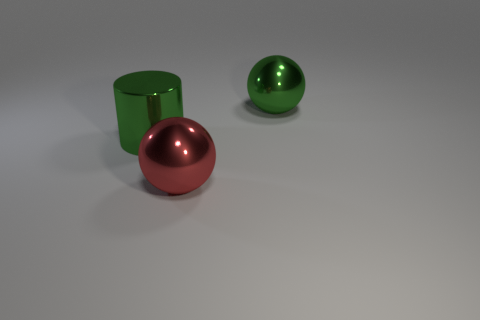There is a large object that is the same color as the cylinder; what is it made of?
Your response must be concise. Metal. There is a big green metal thing right of the red shiny ball; is its shape the same as the shiny thing that is in front of the big green cylinder?
Offer a terse response. Yes. What is the material of the green ball that is the same size as the red metallic thing?
Keep it short and to the point. Metal. Are the green thing that is right of the red metal ball and the ball in front of the large green metal ball made of the same material?
Give a very brief answer. Yes. The green object that is the same size as the shiny cylinder is what shape?
Give a very brief answer. Sphere. What number of other things are the same color as the large shiny cylinder?
Your answer should be very brief. 1. What color is the shiny sphere in front of the large green metal ball?
Keep it short and to the point. Red. How many other objects are the same material as the big green ball?
Give a very brief answer. 2. Is the number of big green shiny things that are in front of the large green sphere greater than the number of metallic balls that are on the right side of the red metal thing?
Make the answer very short. No. How many green shiny things are to the left of the cylinder?
Provide a short and direct response. 0. 